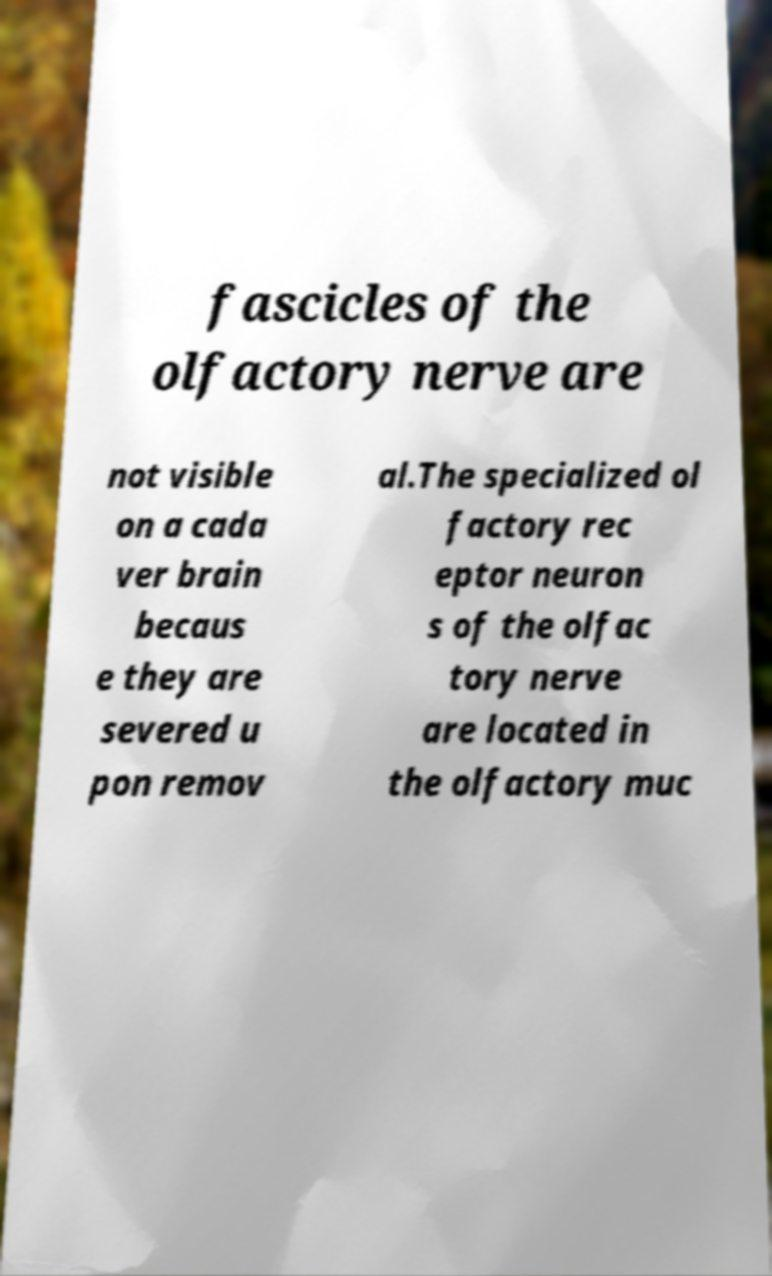There's text embedded in this image that I need extracted. Can you transcribe it verbatim? fascicles of the olfactory nerve are not visible on a cada ver brain becaus e they are severed u pon remov al.The specialized ol factory rec eptor neuron s of the olfac tory nerve are located in the olfactory muc 